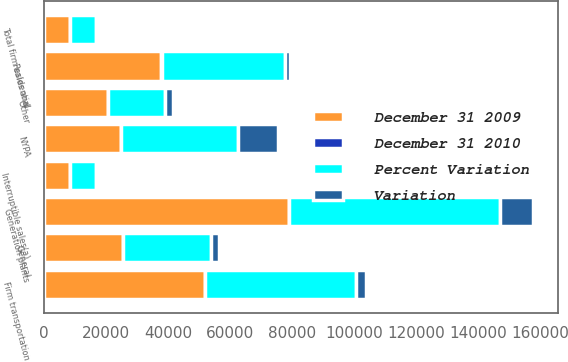Convert chart to OTSL. <chart><loc_0><loc_0><loc_500><loc_500><stacked_bar_chart><ecel><fcel>Residential<fcel>General<fcel>Firm transportation<fcel>Total firm sales and<fcel>Interruptible sales(a)<fcel>NYPA<fcel>Generation plants<fcel>Other<nl><fcel>December 31 2009<fcel>37963<fcel>25629<fcel>51859<fcel>8373<fcel>8521<fcel>24890<fcel>78880<fcel>20786<nl><fcel>Percent Variation<fcel>39749<fcel>28245<fcel>48671<fcel>8373<fcel>8225<fcel>37764<fcel>68157<fcel>18297<nl><fcel>Variation<fcel>1786<fcel>2616<fcel>3188<fcel>1214<fcel>296<fcel>12874<fcel>10723<fcel>2489<nl><fcel>December 31 2010<fcel>4.5<fcel>9.3<fcel>6.6<fcel>1<fcel>6.6<fcel>34.1<fcel>15.7<fcel>13.6<nl></chart> 